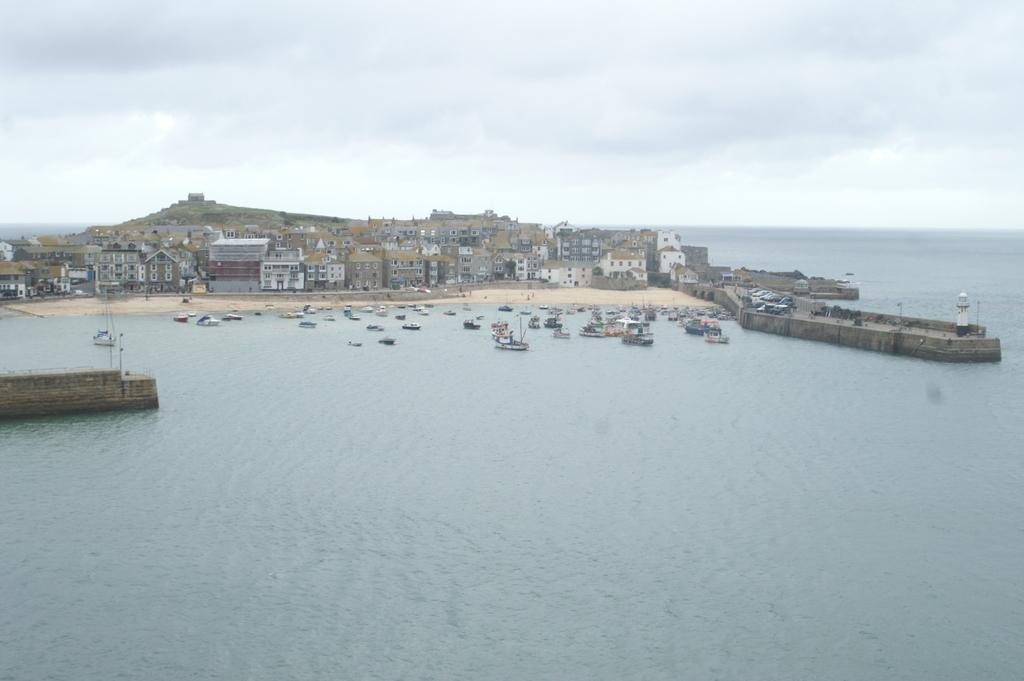What is happening on the water in the image? There are boats on water in the image. What is happening on the road in the image? There are vehicles on the road in the image. What type of structures can be seen in the image? There are buildings with windows in the image. What geographical feature is present in the image? There is a hill in the image. What can be seen in the background of the image? The sky with clouds is visible in the background of the image. Where is the field located in the image? There is no field present in the image. What type of learning is taking place in the image? There is no learning activity depicted in the image. 